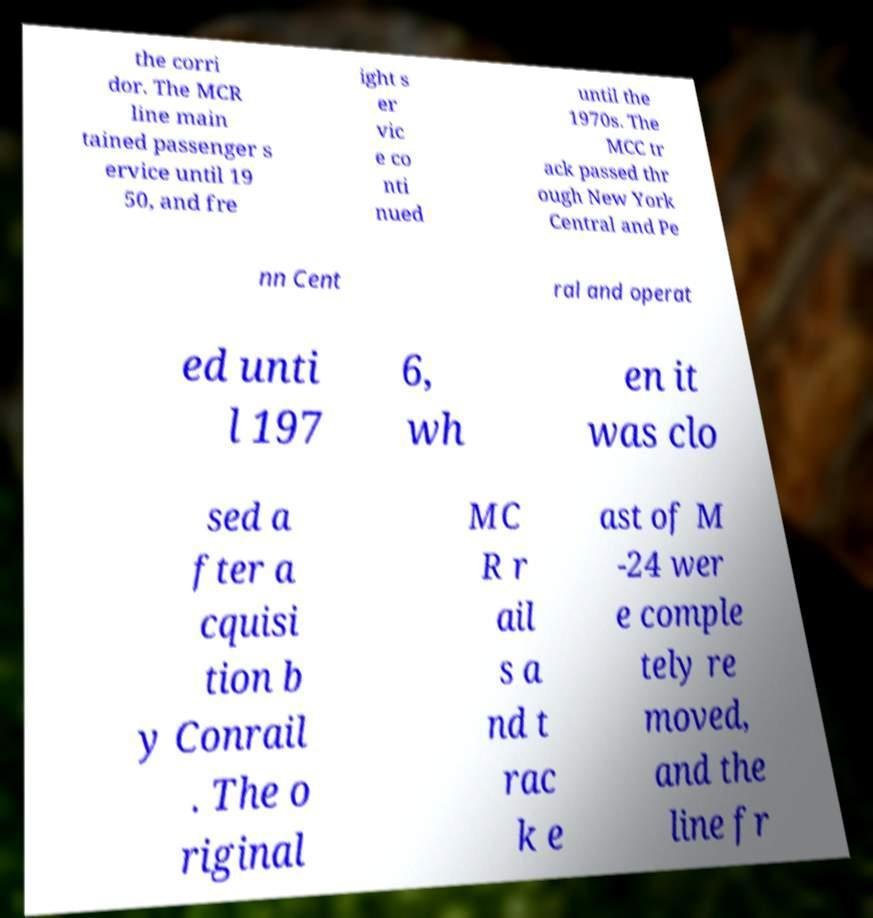Can you read and provide the text displayed in the image?This photo seems to have some interesting text. Can you extract and type it out for me? the corri dor. The MCR line main tained passenger s ervice until 19 50, and fre ight s er vic e co nti nued until the 1970s. The MCC tr ack passed thr ough New York Central and Pe nn Cent ral and operat ed unti l 197 6, wh en it was clo sed a fter a cquisi tion b y Conrail . The o riginal MC R r ail s a nd t rac k e ast of M -24 wer e comple tely re moved, and the line fr 